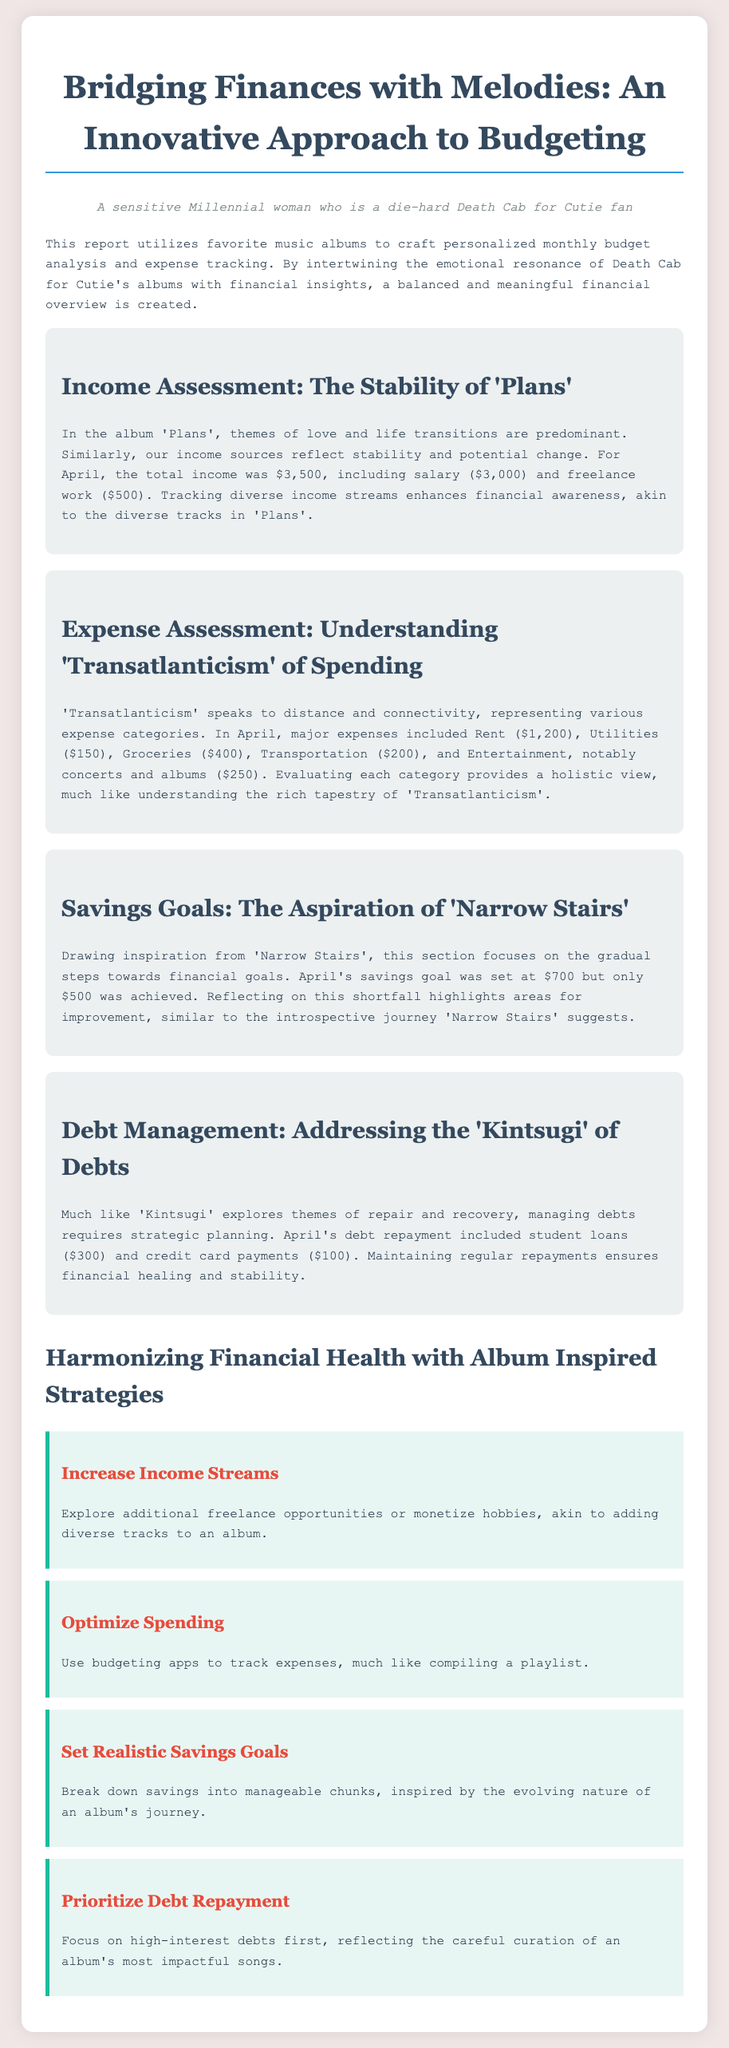what was the total income in April? The total income consists of salary and freelance work, which totals $3,500.
Answer: $3,500 how much was spent on rent? The document lists rent as one of the major expenses, which is $1,200.
Answer: $1,200 what is the savings goal for April? The savings goal for the month is explicitly stated as $700.
Answer: $700 how much was actually saved in April? The document indicates that only $500 was saved, which is less than the goal.
Answer: $500 what theme does 'Transatlanticism' represent in terms of expenses? The album's themes connect to the evaluation of various expenses throughout the month.
Answer: Distance and connectivity how much was allocated for entertainment in April? The document specifically mentions entertainment expenses amounting to $250.
Answer: $250 what type of approach does the document suggest for increasing income? The recommendation encourages exploring additional freelance opportunities or monetizing hobbies.
Answer: Additional freelance opportunities which album theme is related to debt management? The theme of 'Kintsugi' relates to repair and recovery, which parallels debt management.
Answer: Kintsugi what was the goal set for savings in the document? The goal aimed for savings is indicated, which is $700 for April.
Answer: $700 